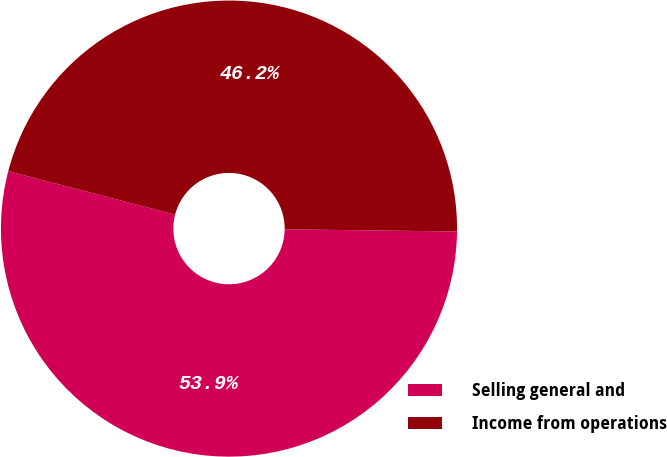<chart> <loc_0><loc_0><loc_500><loc_500><pie_chart><fcel>Selling general and<fcel>Income from operations<nl><fcel>53.85%<fcel>46.15%<nl></chart> 